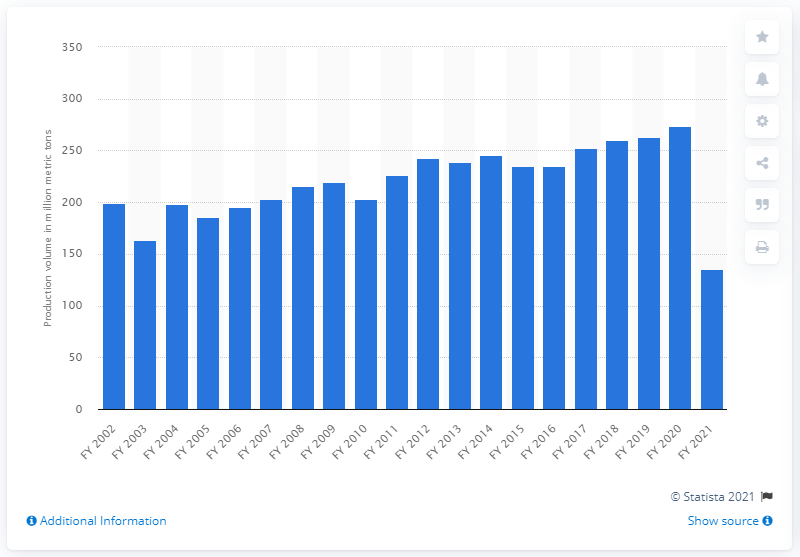Indicate a few pertinent items in this graphic. At the end of the financial year 2021, it is estimated that approximately 135.21 metric tons of cereals were produced in India. 